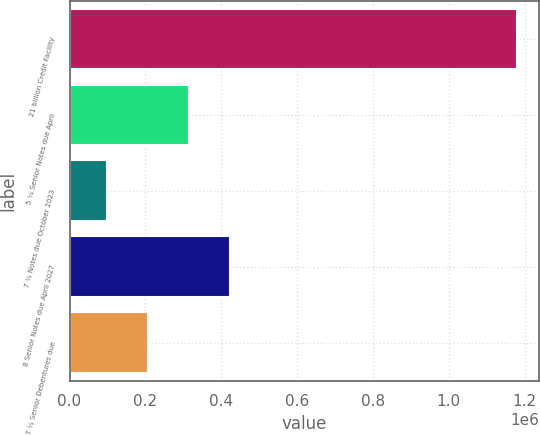Convert chart. <chart><loc_0><loc_0><loc_500><loc_500><bar_chart><fcel>21 billion Credit Facility<fcel>5 ¼ Senior Notes due April<fcel>7 ¼ Notes due October 2023<fcel>8 Senior Notes due April 2027<fcel>7 ¼ Senior Debentures due<nl><fcel>1.18e+06<fcel>316000<fcel>100000<fcel>424000<fcel>208000<nl></chart> 